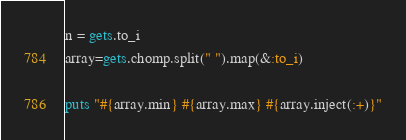Convert code to text. <code><loc_0><loc_0><loc_500><loc_500><_Ruby_>n = gets.to_i
array=gets.chomp.split(" ").map(&:to_i)

puts "#{array.min} #{array.max} #{array.inject(:+)}"
</code> 